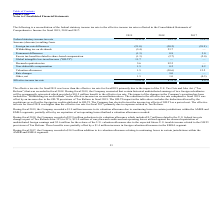According to Plexus's financial document, What was the company's addition to its valuation allowance during Fiscal 2017? According to the financial document, 14.9 (in millions). The relevant text states: "During fiscal 2017, the Company recorded a $14.9 million addition to its valuation allowance relating to continuing losses in certain jurisdictions..." Also, What was the foreign tax rate differences in 2017? According to the financial document, (39.9) (percentage). The relevant text states: "Foreign tax rate differences (21.0) (30.2) (39.9)..." Also, What was the Federal statutory income tax rate in 2019? According to the financial document, 21.0 (percentage). The relevant text states: "Federal statutory income tax rate 21.0 % 24.5 % 35.0 %..." Also, How many years did the Federal statutory income tax rate exceed 30.0%? Based on the analysis, there are 1 instances. The counting process: 2017. Additionally, Which years did the increase resulting from Non-deductible compensation exceed 1%? According to the financial document, 2019. The relevant text states: "2019 2018 2017..." Also, can you calculate: What was the change in the increase resulting from permanent differences between 2017 and 2018? Based on the calculation: 0.8-3.0, the result is -2.2 (percentage). This is based on the information: "Permanent differences (1.3) 0.8 3.0 Permanent differences (1.3) 0.8 3.0..." The key data points involved are: 0.8, 3.0. 